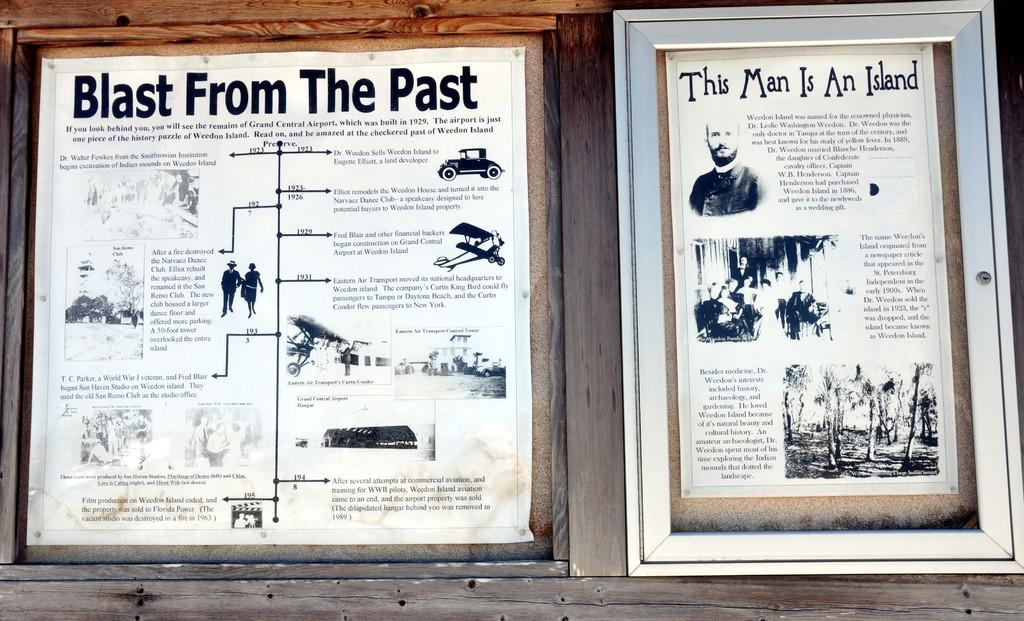Provide a one-sentence caption for the provided image. Two posters are on a wall with one being titled Blast From The Past. 